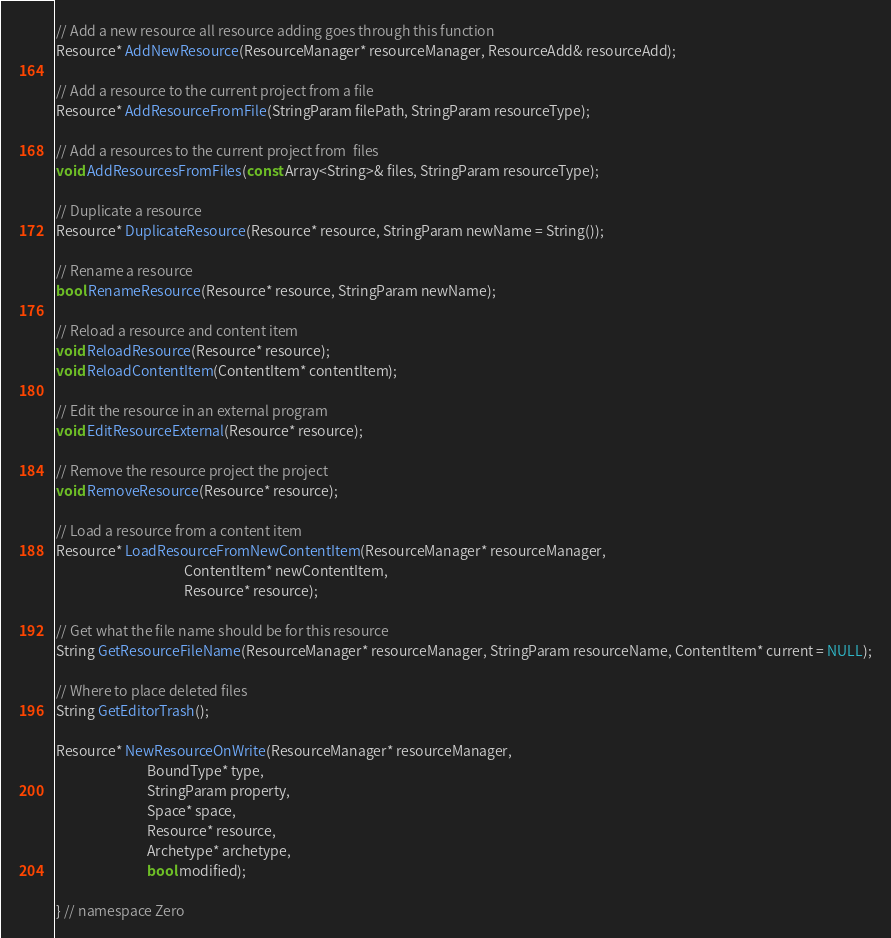<code> <loc_0><loc_0><loc_500><loc_500><_C++_>// Add a new resource all resource adding goes through this function
Resource* AddNewResource(ResourceManager* resourceManager, ResourceAdd& resourceAdd);

// Add a resource to the current project from a file
Resource* AddResourceFromFile(StringParam filePath, StringParam resourceType);

// Add a resources to the current project from  files
void AddResourcesFromFiles(const Array<String>& files, StringParam resourceType);

// Duplicate a resource
Resource* DuplicateResource(Resource* resource, StringParam newName = String());

// Rename a resource
bool RenameResource(Resource* resource, StringParam newName);

// Reload a resource and content item
void ReloadResource(Resource* resource);
void ReloadContentItem(ContentItem* contentItem);

// Edit the resource in an external program
void EditResourceExternal(Resource* resource);

// Remove the resource project the project
void RemoveResource(Resource* resource);

// Load a resource from a content item
Resource* LoadResourceFromNewContentItem(ResourceManager* resourceManager,
                                         ContentItem* newContentItem,
                                         Resource* resource);

// Get what the file name should be for this resource
String GetResourceFileName(ResourceManager* resourceManager, StringParam resourceName, ContentItem* current = NULL);

// Where to place deleted files
String GetEditorTrash();

Resource* NewResourceOnWrite(ResourceManager* resourceManager,
                             BoundType* type,
                             StringParam property,
                             Space* space,
                             Resource* resource,
                             Archetype* archetype,
                             bool modified);

} // namespace Zero
</code> 